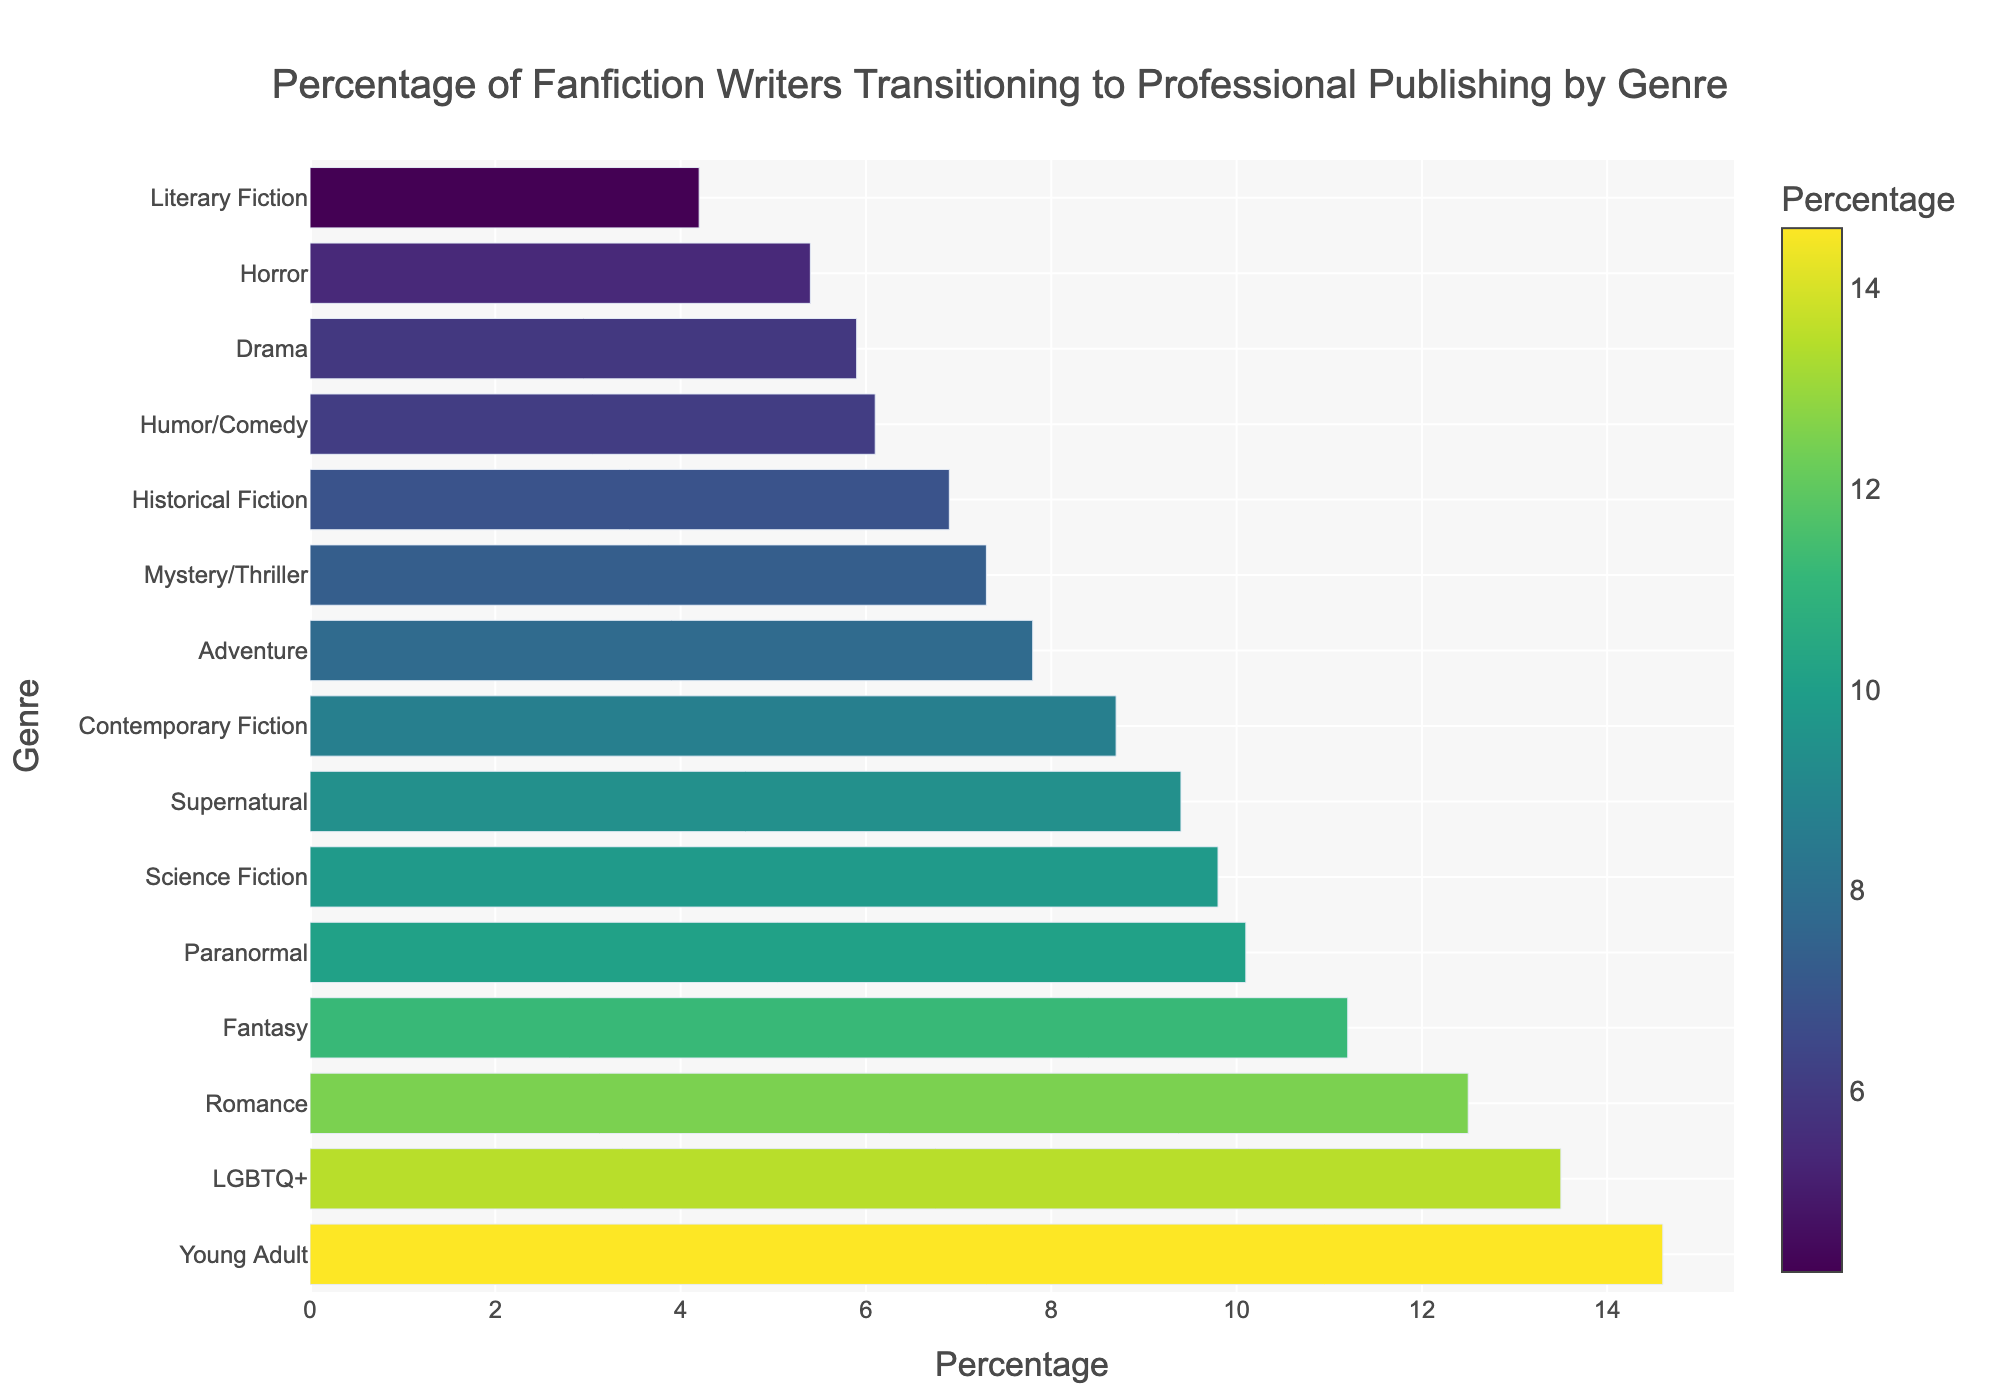What's the most common genre for fanfiction writers who transition to professional publishing? The bar chart shows that "Young Adult" has the highest percentage, indicating it is the most common genre for fanfiction writers transitioning to professional publishing.
Answer: Young Adult Which genre has the lowest percentage of fanfiction writers transitioning to professional publishing? Looking at the bar chart, "Literary Fiction" has the lowest percentage compared to other genres.
Answer: Literary Fiction How much higher is the percentage for Romance compared to Horror? The percentage for Romance is 12.5%, and for Horror, it is 5.4%. The difference is 12.5% - 5.4% = 7.1%.
Answer: 7.1% What is the combined percentage of fanfiction writers who transition to professional publishing in the genres of Fantasy and LGBTQ+? The percentage for Fantasy is 11.2% and for LGBTQ+ is 13.5%. Adding them gives 11.2% + 13.5% = 24.7%.
Answer: 24.7% Which three genres have the highest percentages of fanfiction writers transitioning to professional publishing? The three genres with the highest percentages are: Young Adult (14.6%), LGBTQ+ (13.5%), and Romance (12.5%), as shown by the heights of their bars.
Answer: Young Adult, LGBTQ+, Romance Is the percentage of fanfiction writers transitioning to professional publishing in Contemporary Fiction higher than in Mystery/Thriller? The percentage for Contemporary Fiction is 8.7%, whereas for Mystery/Thriller, it is 7.3%. Therefore, Contemporary Fiction has a higher percentage.
Answer: Yes What is the difference in percentage between Adventure and Drama? The percentage for Adventure is 7.8%, and for Drama, it is 5.9%. The difference is 7.8% - 5.9% = 1.9%.
Answer: 1.9% Which genre has a percentage closest to the average percentage of all genres? To find the genre closest to the average, we calculate the average of all percentages. The average is (12.5 + 9.8 + 11.2 + 7.3 + 14.6 + 6.9 + 5.4 + 4.2 + 8.7 + 10.1 + 13.5 + 7.8 + 6.1 + 5.9 + 9.4) / 15 = 8.86%. The closest genre to 8.86% is Contemporary Fiction at 8.7%.
Answer: Contemporary Fiction Is the percentage for Paranormal fanfiction writers transitioning to professional publishing more than twice that for Literary Fiction? The percentage for Paranormal is 10.1%, and for Literary Fiction, it is 4.2%. Twice 4.2% is 8.4%. Since 10.1% > 8.4%, Paranormal is more than twice that of Literary Fiction.
Answer: Yes 